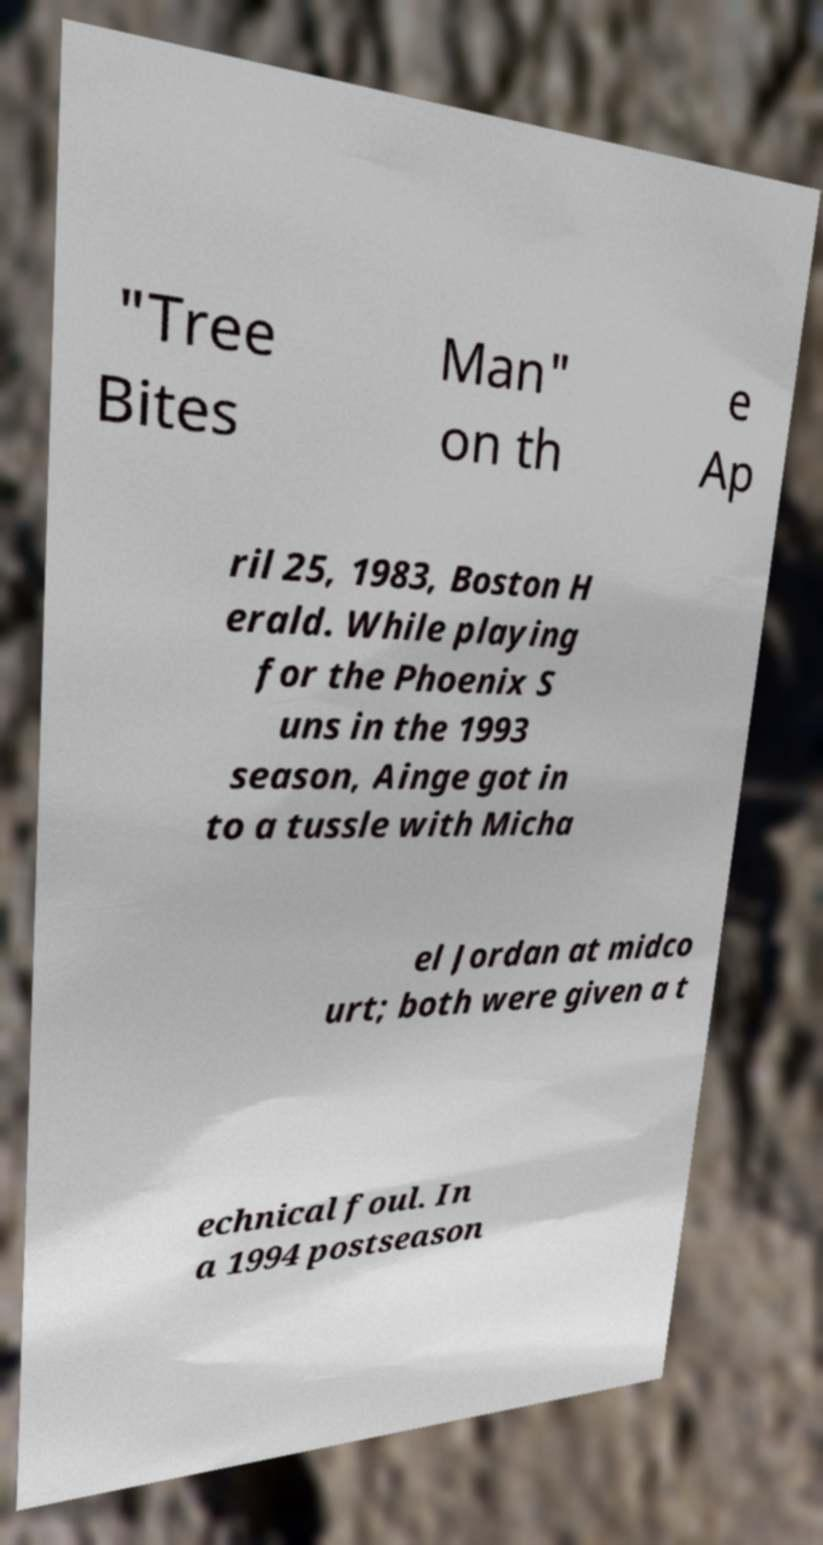I need the written content from this picture converted into text. Can you do that? "Tree Bites Man" on th e Ap ril 25, 1983, Boston H erald. While playing for the Phoenix S uns in the 1993 season, Ainge got in to a tussle with Micha el Jordan at midco urt; both were given a t echnical foul. In a 1994 postseason 